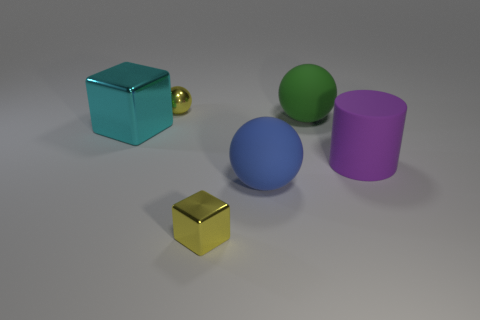What number of rubber objects are there?
Give a very brief answer. 3. There is a cylinder that is the same material as the large green object; what is its color?
Offer a terse response. Purple. What number of big things are blue things or yellow cubes?
Ensure brevity in your answer.  1. There is a large blue rubber sphere; what number of cyan metal objects are on the right side of it?
Make the answer very short. 0. There is another rubber thing that is the same shape as the blue matte object; what color is it?
Provide a succinct answer. Green. How many metallic things are either large blue spheres or cyan cubes?
Offer a very short reply. 1. There is a tiny metal thing that is on the right side of the tiny shiny thing behind the cyan shiny object; are there any tiny metal things right of it?
Your answer should be very brief. No. What color is the big cylinder?
Your answer should be very brief. Purple. Is the shape of the shiny object that is on the right side of the yellow metallic sphere the same as  the big metal object?
Give a very brief answer. Yes. How many objects are cylinders or small things in front of the tiny yellow sphere?
Ensure brevity in your answer.  2. 